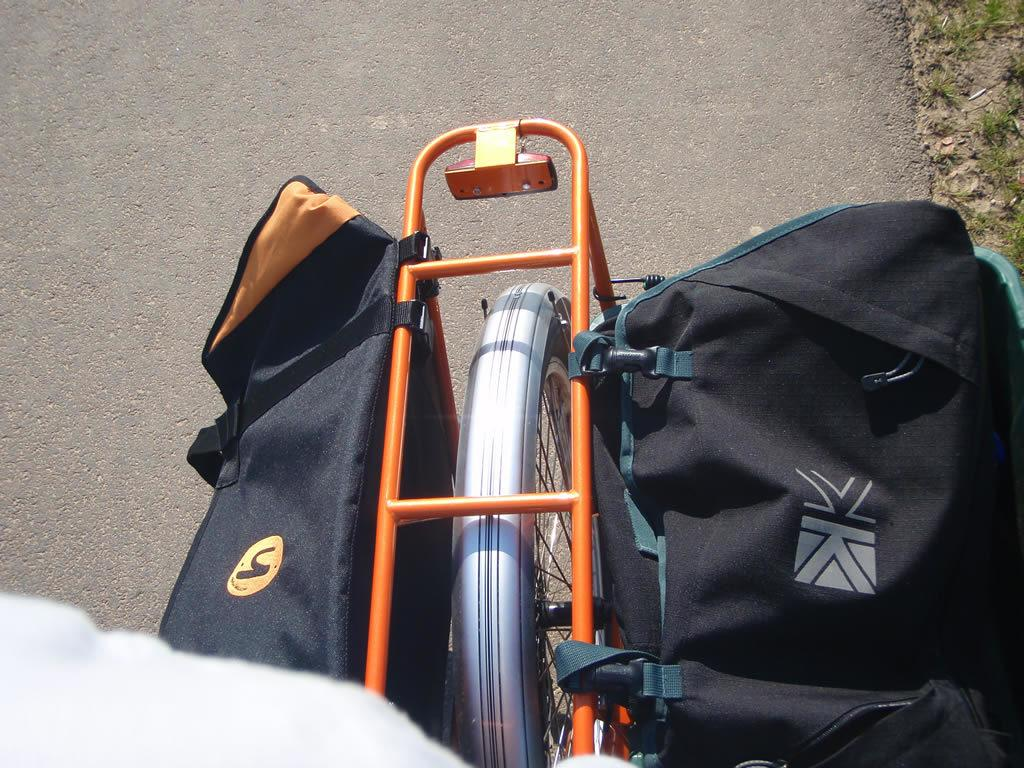What is on the bicycle in the image? There are two bags on the bicycle. Where is the bicycle located? The bicycle is on the road. What type of music can be heard coming from the bags on the bicycle? There is no indication of music or any sounds coming from the bags on the bicycle in the image. 